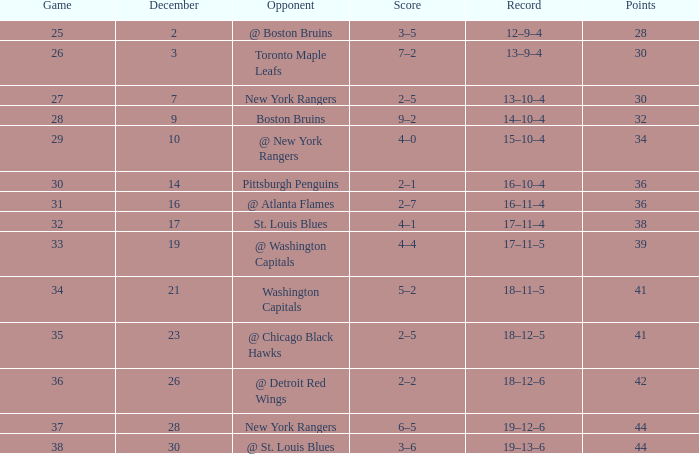What score possesses a record of 18-11-5? 5–2. 